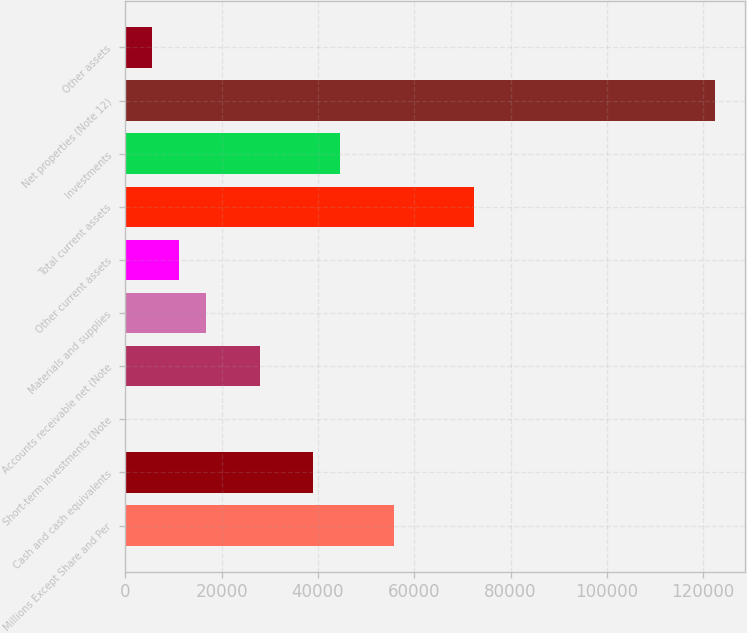<chart> <loc_0><loc_0><loc_500><loc_500><bar_chart><fcel>Millions Except Share and Per<fcel>Cash and cash equivalents<fcel>Short-term investments (Note<fcel>Accounts receivable net (Note<fcel>Materials and supplies<fcel>Other current assets<fcel>Total current assets<fcel>Investments<fcel>Net properties (Note 12)<fcel>Other assets<nl><fcel>55718<fcel>39020.6<fcel>60<fcel>27889<fcel>16757.4<fcel>11191.6<fcel>72415.4<fcel>44586.4<fcel>122508<fcel>5625.8<nl></chart> 